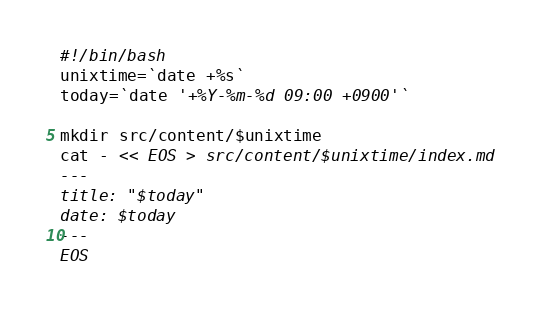<code> <loc_0><loc_0><loc_500><loc_500><_Bash_>#!/bin/bash
unixtime=`date +%s`
today=`date '+%Y-%m-%d 09:00 +0900'`

mkdir src/content/$unixtime
cat - << EOS > src/content/$unixtime/index.md
---
title: "$today"
date: $today
---
EOS</code> 